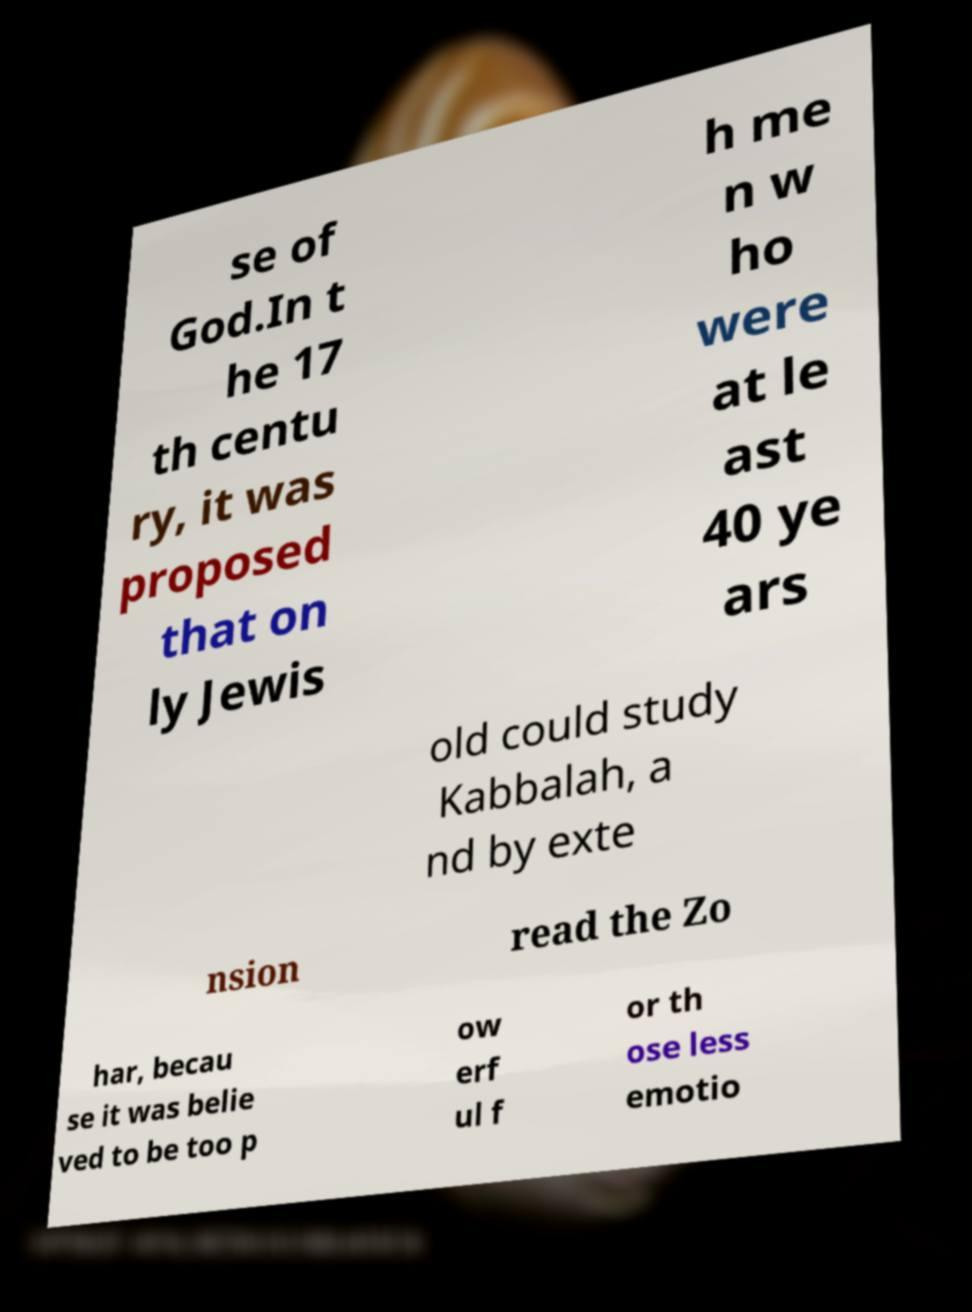Please read and relay the text visible in this image. What does it say? se of God.In t he 17 th centu ry, it was proposed that on ly Jewis h me n w ho were at le ast 40 ye ars old could study Kabbalah, a nd by exte nsion read the Zo har, becau se it was belie ved to be too p ow erf ul f or th ose less emotio 